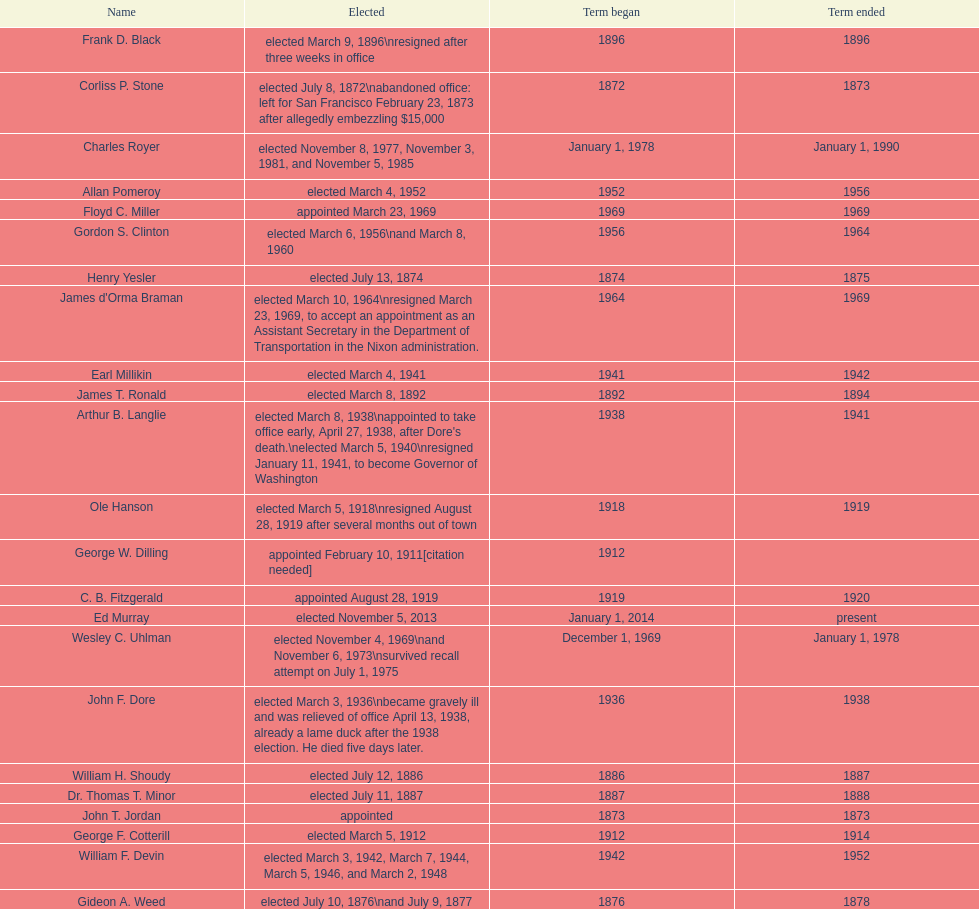Who was mayor of seattle, washington before being appointed to department of transportation during the nixon administration? James d'Orma Braman. 